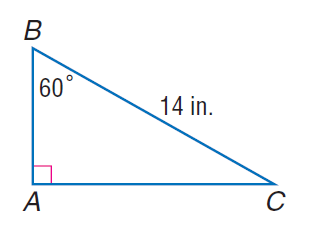Question: Find A C.
Choices:
A. 7
B. 7 \sqrt { 3 }
C. 14
D. 14 \sqrt { 3 }
Answer with the letter. Answer: B 